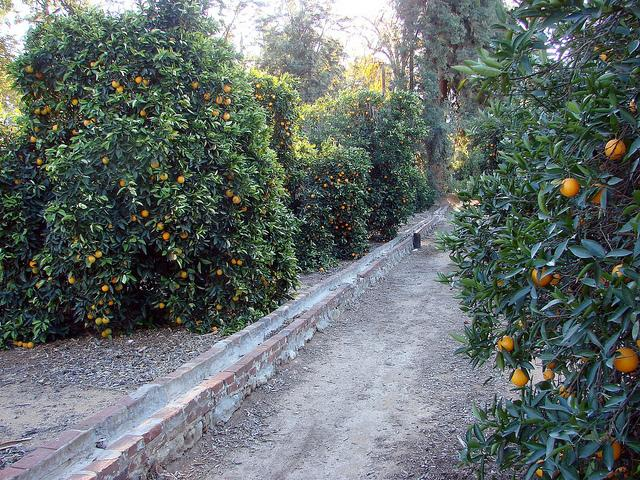What weather is greatest threat to this crop? frost 